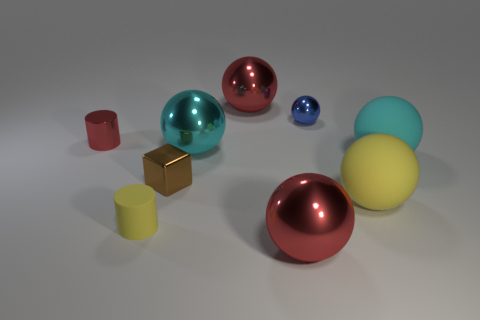What is the size of the other rubber thing that is the same color as the tiny matte thing?
Your answer should be compact. Large. What is the color of the sphere that is the same size as the metal block?
Offer a very short reply. Blue. There is a cyan sphere on the right side of the big cyan ball that is behind the large cyan sphere right of the small blue shiny sphere; what is it made of?
Ensure brevity in your answer.  Rubber. Is the color of the rubber cylinder the same as the sphere that is behind the small ball?
Ensure brevity in your answer.  No. What number of things are either yellow matte things that are left of the big yellow thing or objects on the left side of the cyan matte sphere?
Your answer should be very brief. 8. What is the shape of the yellow matte object that is to the right of the red metallic ball that is behind the tiny brown cube?
Keep it short and to the point. Sphere. Are there any small brown blocks made of the same material as the small blue ball?
Your response must be concise. Yes. The tiny shiny thing that is the same shape as the large cyan metal object is what color?
Offer a terse response. Blue. Are there fewer big rubber things on the right side of the small shiny sphere than brown things behind the brown object?
Make the answer very short. No. What number of other objects are the same shape as the blue metallic object?
Make the answer very short. 5. 